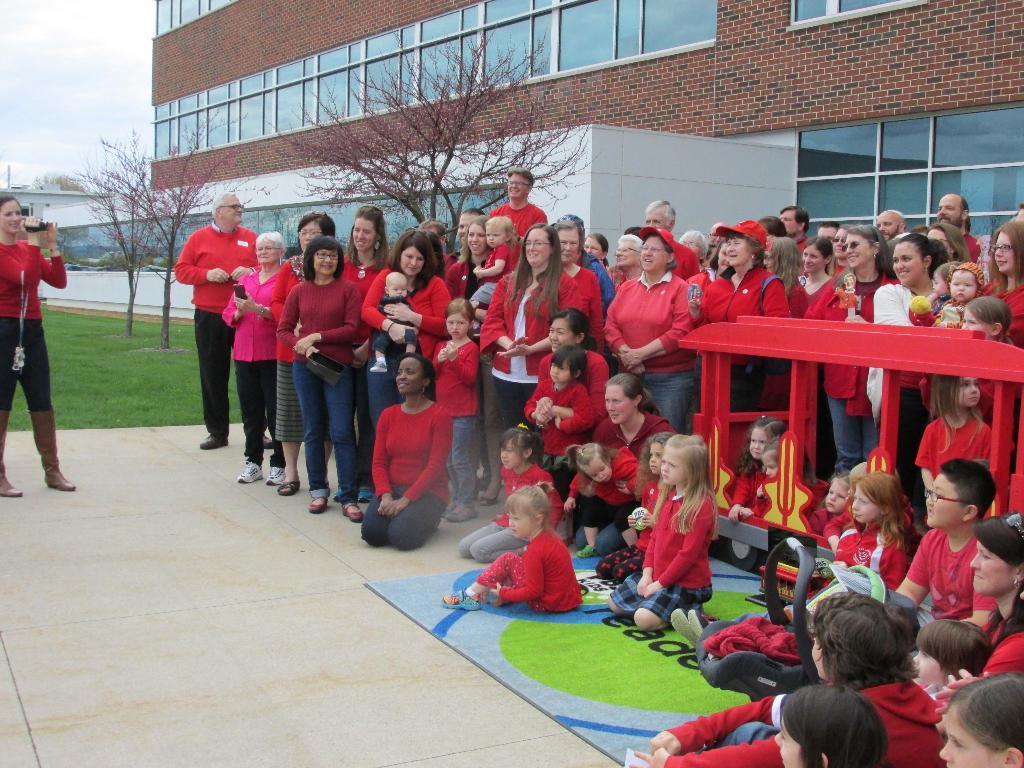Can you describe this image briefly? Here we can see people, trees, buildings, grass and sky. This person is holding a camera. Children are inside this toy vehicle. In-front of these people there is a baby chair. To this building there are glass windows. 